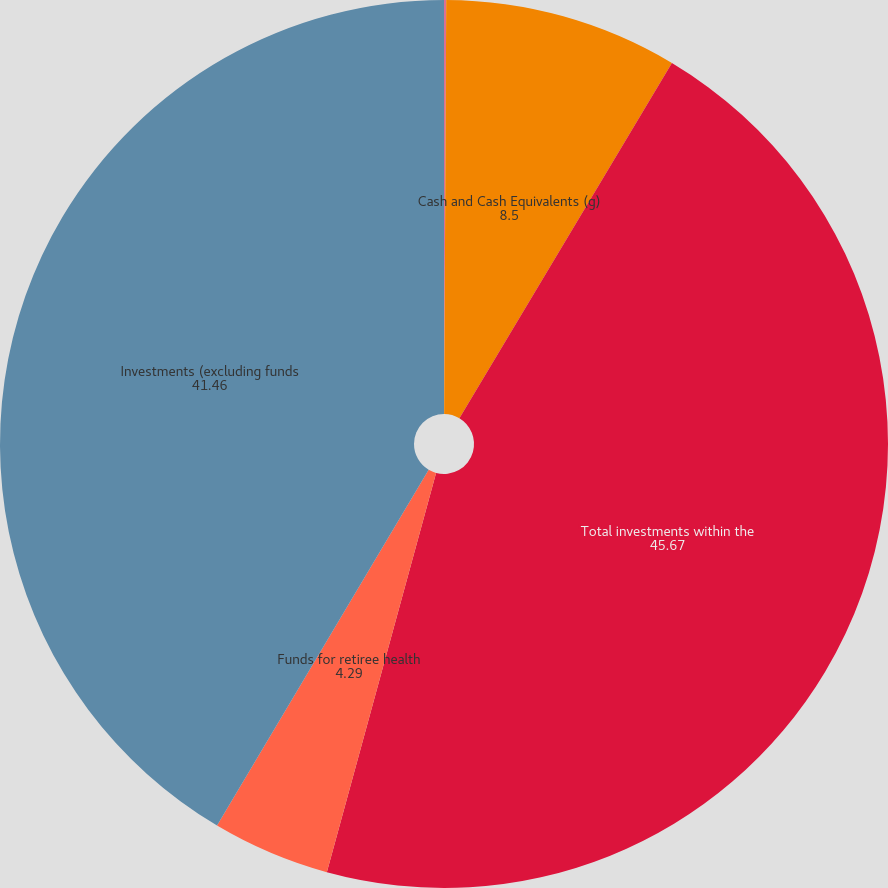Convert chart. <chart><loc_0><loc_0><loc_500><loc_500><pie_chart><fcel>US Equity (a)<fcel>Cash and Cash Equivalents (g)<fcel>Total investments within the<fcel>Funds for retiree health<fcel>Investments (excluding funds<nl><fcel>0.08%<fcel>8.5%<fcel>45.67%<fcel>4.29%<fcel>41.46%<nl></chart> 